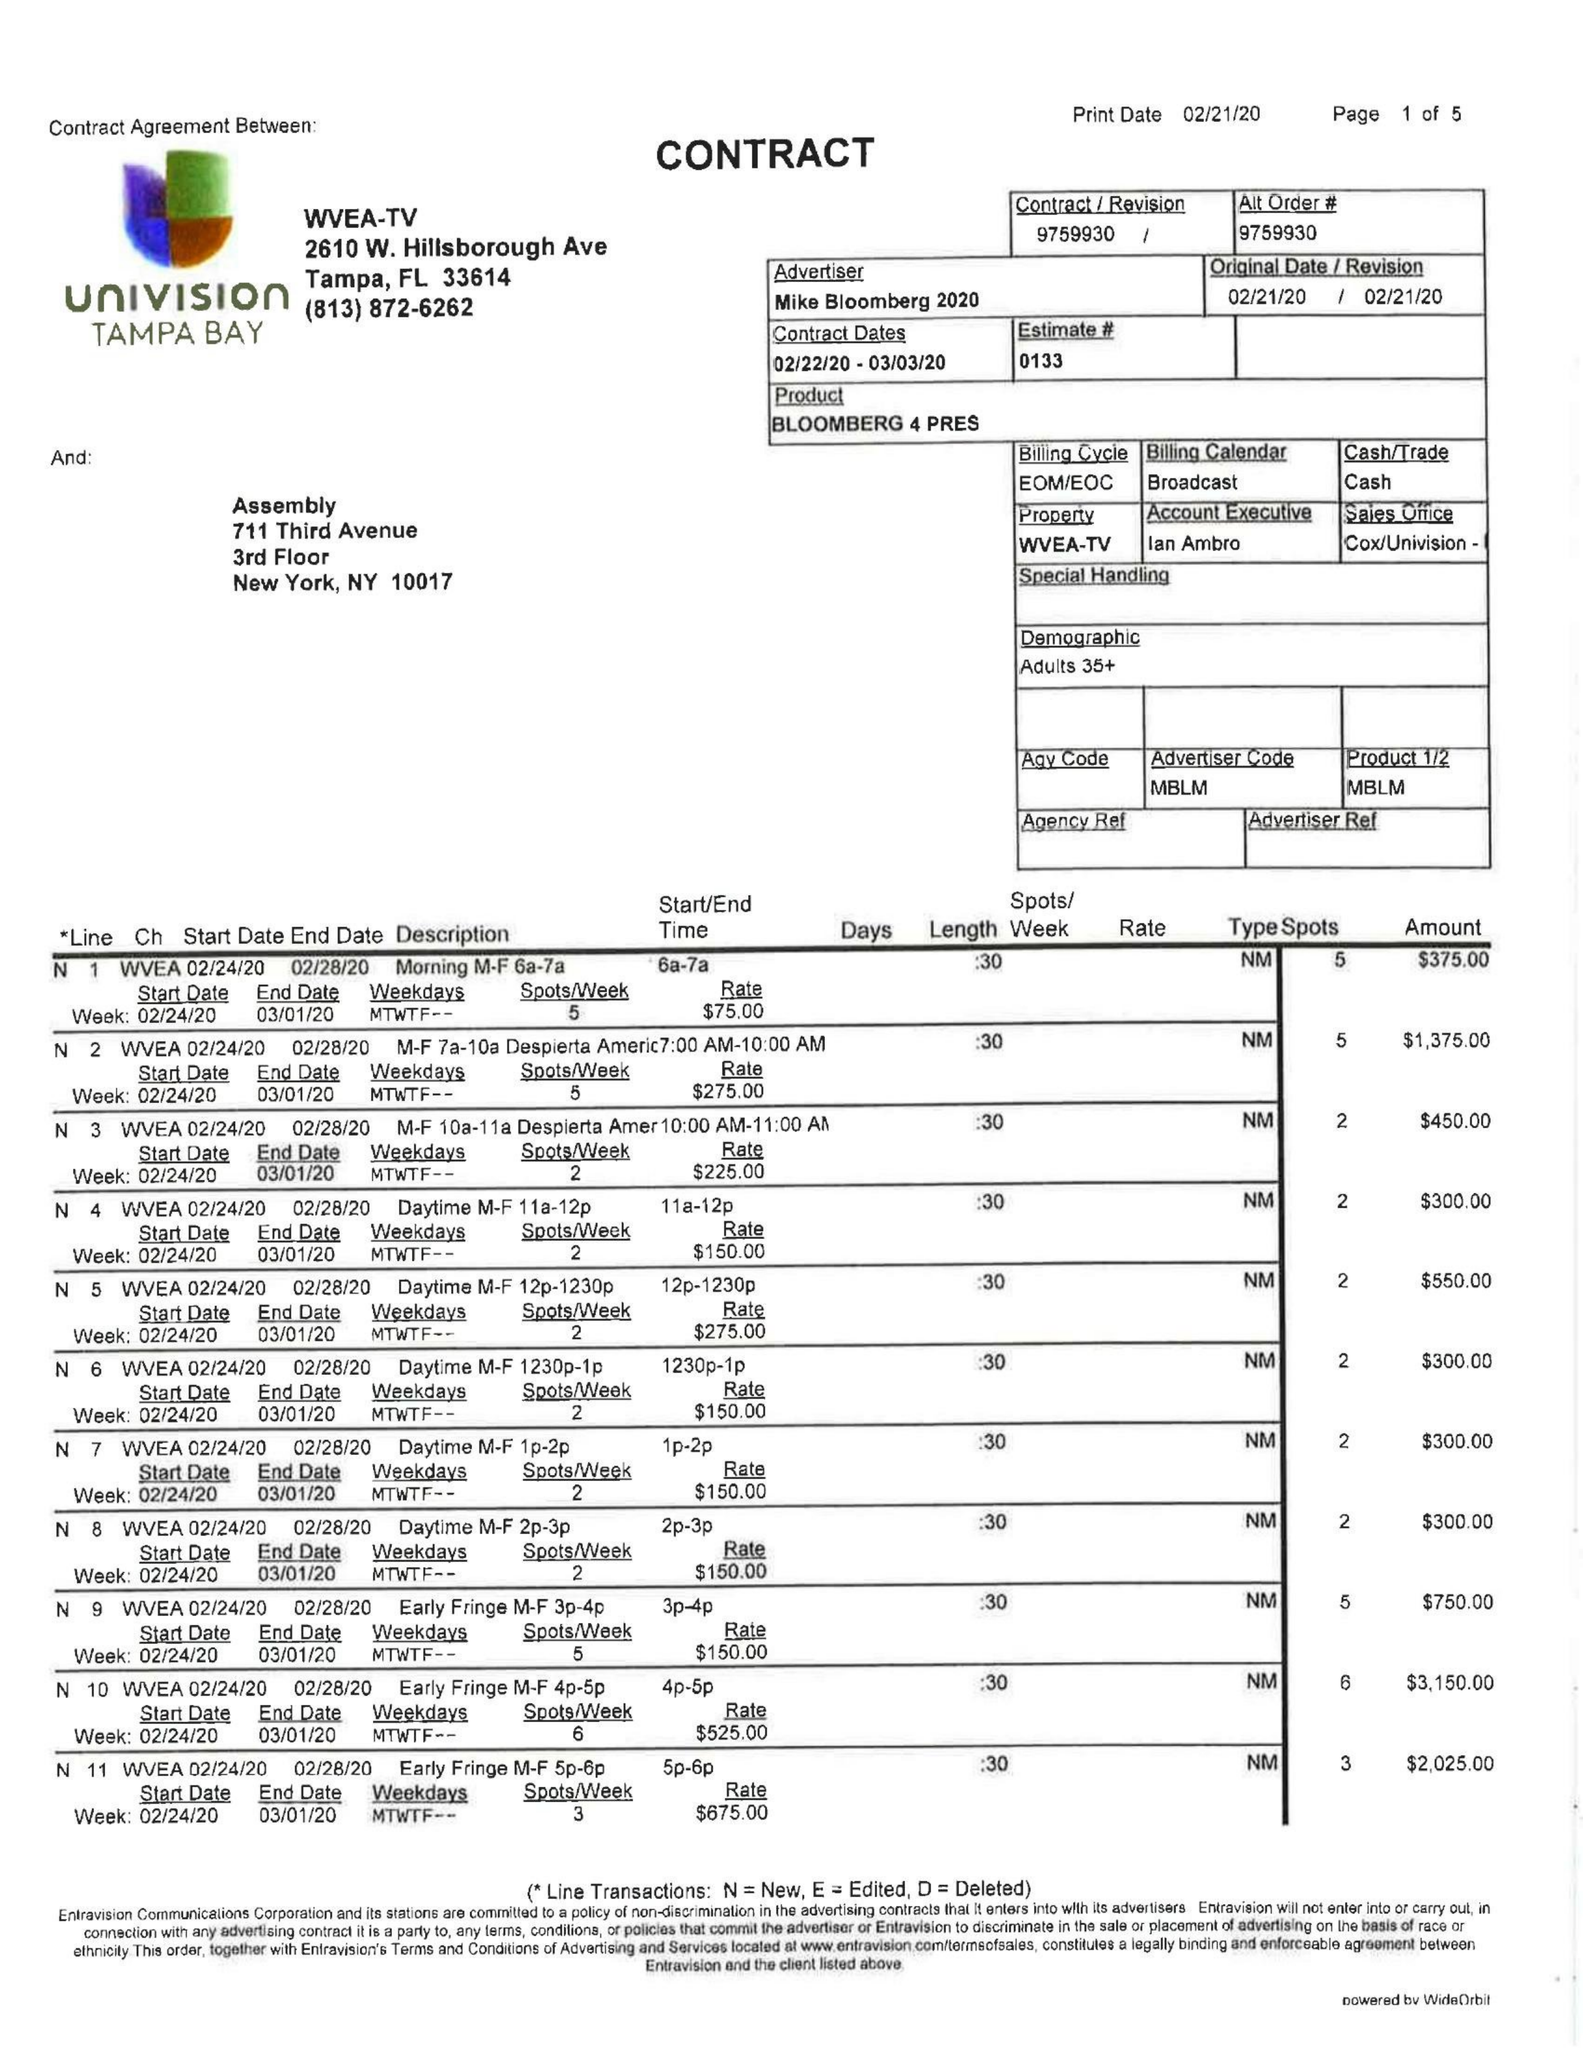What is the value for the flight_to?
Answer the question using a single word or phrase. 03/03/20 